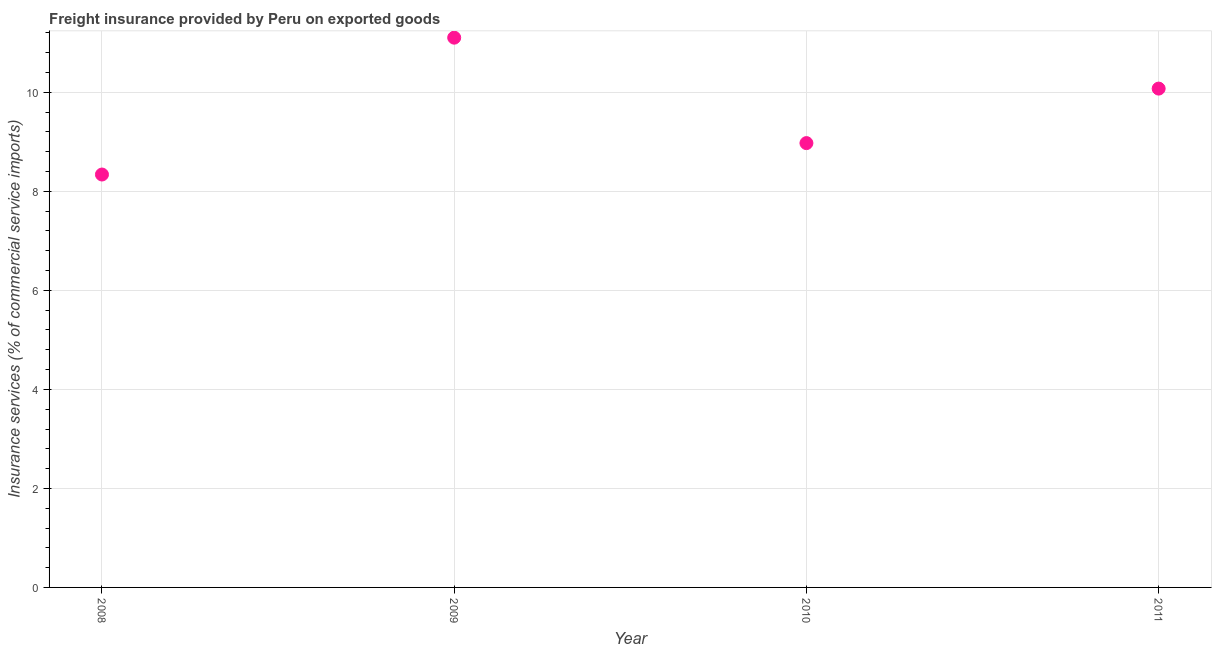What is the freight insurance in 2009?
Your answer should be compact. 11.1. Across all years, what is the maximum freight insurance?
Give a very brief answer. 11.1. Across all years, what is the minimum freight insurance?
Offer a very short reply. 8.34. In which year was the freight insurance maximum?
Give a very brief answer. 2009. What is the sum of the freight insurance?
Make the answer very short. 38.5. What is the difference between the freight insurance in 2008 and 2011?
Make the answer very short. -1.74. What is the average freight insurance per year?
Your answer should be very brief. 9.62. What is the median freight insurance?
Your answer should be compact. 9.53. Do a majority of the years between 2010 and 2008 (inclusive) have freight insurance greater than 7.2 %?
Ensure brevity in your answer.  No. What is the ratio of the freight insurance in 2008 to that in 2009?
Your answer should be very brief. 0.75. Is the difference between the freight insurance in 2008 and 2011 greater than the difference between any two years?
Your response must be concise. No. What is the difference between the highest and the second highest freight insurance?
Offer a very short reply. 1.03. What is the difference between the highest and the lowest freight insurance?
Offer a very short reply. 2.76. Does the freight insurance monotonically increase over the years?
Keep it short and to the point. No. What is the difference between two consecutive major ticks on the Y-axis?
Make the answer very short. 2. Does the graph contain any zero values?
Provide a short and direct response. No. What is the title of the graph?
Provide a succinct answer. Freight insurance provided by Peru on exported goods . What is the label or title of the X-axis?
Provide a succinct answer. Year. What is the label or title of the Y-axis?
Offer a very short reply. Insurance services (% of commercial service imports). What is the Insurance services (% of commercial service imports) in 2008?
Provide a short and direct response. 8.34. What is the Insurance services (% of commercial service imports) in 2009?
Provide a succinct answer. 11.1. What is the Insurance services (% of commercial service imports) in 2010?
Your response must be concise. 8.98. What is the Insurance services (% of commercial service imports) in 2011?
Provide a short and direct response. 10.08. What is the difference between the Insurance services (% of commercial service imports) in 2008 and 2009?
Provide a succinct answer. -2.76. What is the difference between the Insurance services (% of commercial service imports) in 2008 and 2010?
Provide a succinct answer. -0.63. What is the difference between the Insurance services (% of commercial service imports) in 2008 and 2011?
Your answer should be very brief. -1.74. What is the difference between the Insurance services (% of commercial service imports) in 2009 and 2010?
Keep it short and to the point. 2.13. What is the difference between the Insurance services (% of commercial service imports) in 2009 and 2011?
Give a very brief answer. 1.03. What is the difference between the Insurance services (% of commercial service imports) in 2010 and 2011?
Provide a succinct answer. -1.1. What is the ratio of the Insurance services (% of commercial service imports) in 2008 to that in 2009?
Your answer should be compact. 0.75. What is the ratio of the Insurance services (% of commercial service imports) in 2008 to that in 2010?
Keep it short and to the point. 0.93. What is the ratio of the Insurance services (% of commercial service imports) in 2008 to that in 2011?
Provide a succinct answer. 0.83. What is the ratio of the Insurance services (% of commercial service imports) in 2009 to that in 2010?
Provide a succinct answer. 1.24. What is the ratio of the Insurance services (% of commercial service imports) in 2009 to that in 2011?
Provide a short and direct response. 1.1. What is the ratio of the Insurance services (% of commercial service imports) in 2010 to that in 2011?
Ensure brevity in your answer.  0.89. 